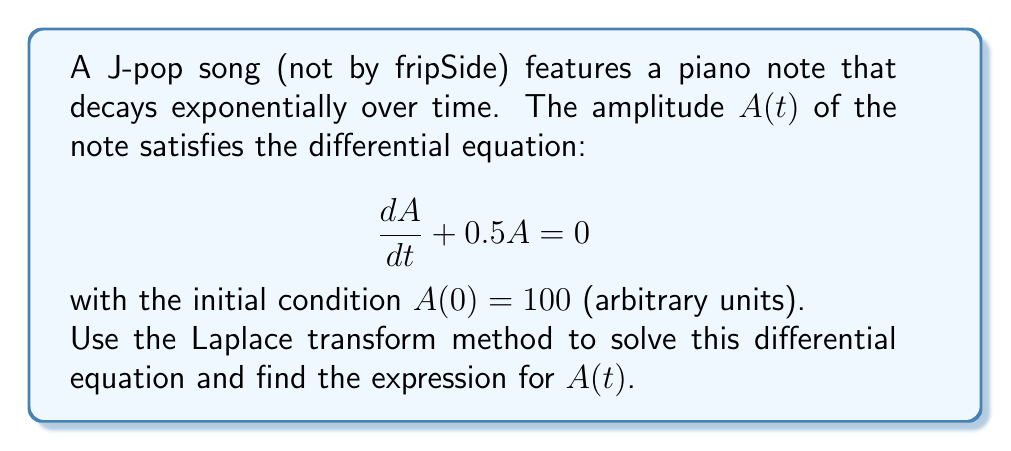Can you answer this question? Let's solve this problem step-by-step using the Laplace transform method:

1) First, let's take the Laplace transform of both sides of the equation:
   
   $$\mathcal{L}\left\{\frac{dA}{dt}\right\} + 0.5\mathcal{L}\{A\} = 0$$

2) Using the Laplace transform properties:
   
   $$s\mathcal{L}\{A\} - A(0) + 0.5\mathcal{L}\{A\} = 0$$

3) Let $\mathcal{L}\{A\} = F(s)$. Substituting the initial condition $A(0) = 100$:
   
   $$sF(s) - 100 + 0.5F(s) = 0$$

4) Rearranging the equation:
   
   $$(s + 0.5)F(s) = 100$$

5) Solving for $F(s)$:
   
   $$F(s) = \frac{100}{s + 0.5}$$

6) This can be rewritten as:
   
   $$F(s) = \frac{100}{s + 0.5}$$

7) We recognize this as the Laplace transform of an exponential function. The inverse Laplace transform is:
   
   $$A(t) = 100e^{-0.5t}$$

This is the solution to our differential equation.
Answer: $A(t) = 100e^{-0.5t}$ 